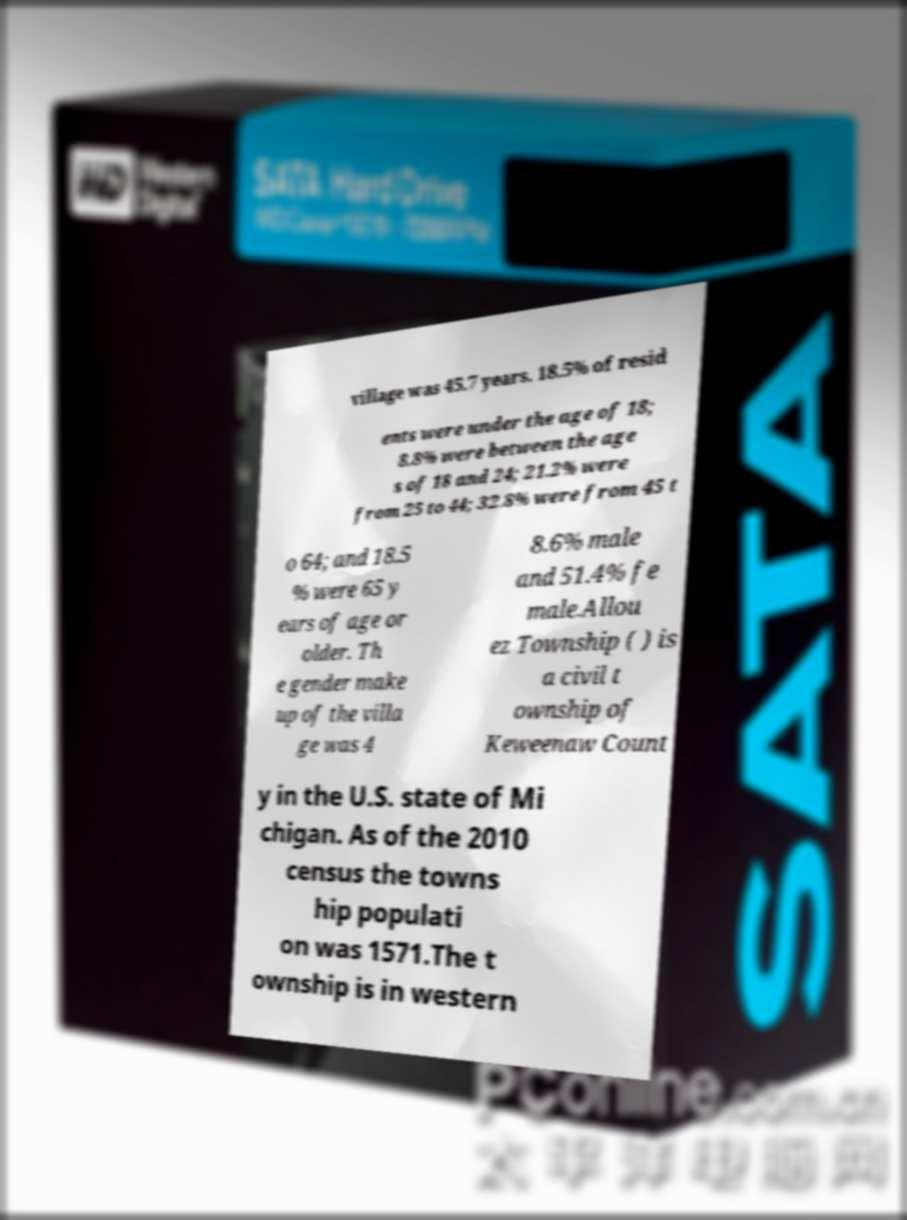Please identify and transcribe the text found in this image. village was 45.7 years. 18.5% of resid ents were under the age of 18; 8.8% were between the age s of 18 and 24; 21.2% were from 25 to 44; 32.8% were from 45 t o 64; and 18.5 % were 65 y ears of age or older. Th e gender make up of the villa ge was 4 8.6% male and 51.4% fe male.Allou ez Township ( ) is a civil t ownship of Keweenaw Count y in the U.S. state of Mi chigan. As of the 2010 census the towns hip populati on was 1571.The t ownship is in western 